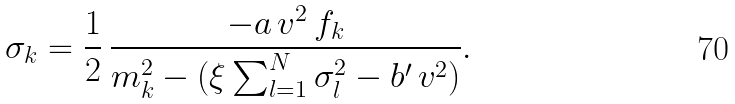<formula> <loc_0><loc_0><loc_500><loc_500>\sigma _ { k } = \frac { 1 } { 2 } \, \frac { - a \, v ^ { 2 } \, f _ { k } } { m ^ { 2 } _ { k } - ( \xi \sum ^ { N } _ { l = 1 } \sigma ^ { 2 } _ { l } - b ^ { \prime } \, v ^ { 2 } ) } .</formula> 